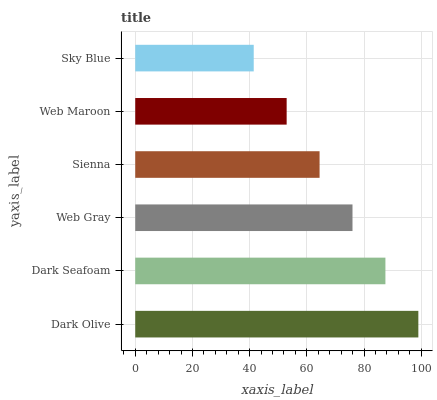Is Sky Blue the minimum?
Answer yes or no. Yes. Is Dark Olive the maximum?
Answer yes or no. Yes. Is Dark Seafoam the minimum?
Answer yes or no. No. Is Dark Seafoam the maximum?
Answer yes or no. No. Is Dark Olive greater than Dark Seafoam?
Answer yes or no. Yes. Is Dark Seafoam less than Dark Olive?
Answer yes or no. Yes. Is Dark Seafoam greater than Dark Olive?
Answer yes or no. No. Is Dark Olive less than Dark Seafoam?
Answer yes or no. No. Is Web Gray the high median?
Answer yes or no. Yes. Is Sienna the low median?
Answer yes or no. Yes. Is Sky Blue the high median?
Answer yes or no. No. Is Sky Blue the low median?
Answer yes or no. No. 